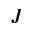<formula> <loc_0><loc_0><loc_500><loc_500>J</formula> 